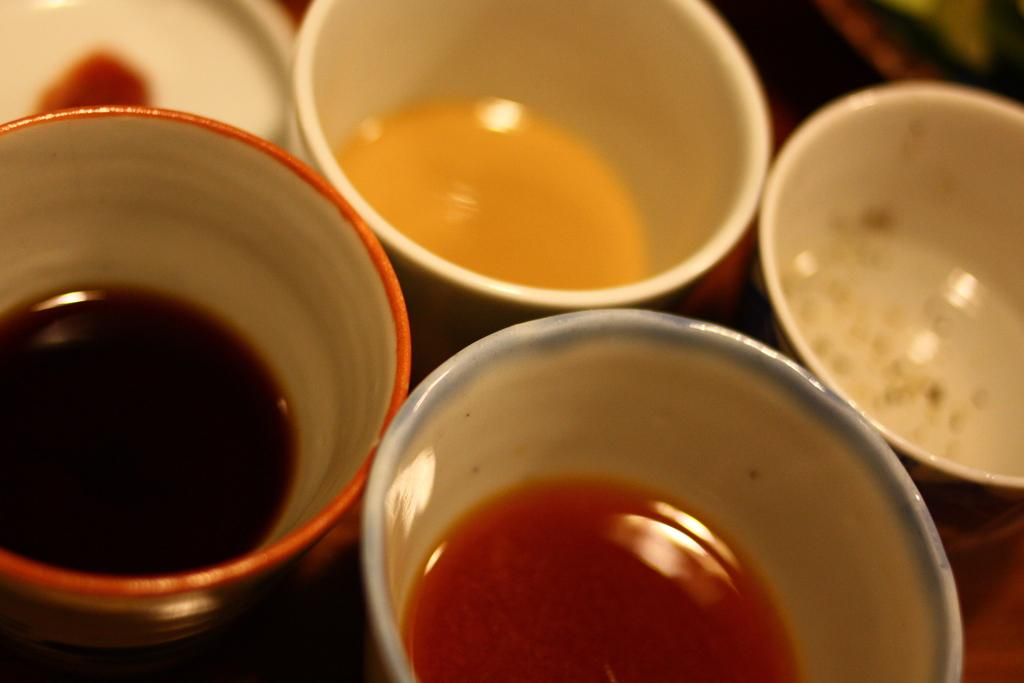What objects are present in the image? A: There are cups in the image. Can you describe the colors of the cups? The cups are cream, orange, and blue in color. What is inside the cups? There are liquids in the cups. What colors are the liquids? The liquids are black and orange in color. What causes the stomach to feel uneasy after consuming the liquids in the cups? The provided facts do not mention any specific ingredients or properties of the liquids that could cause discomfort. Therefore, we cannot determine the cause of any potential stomach discomfort from the image alone. 